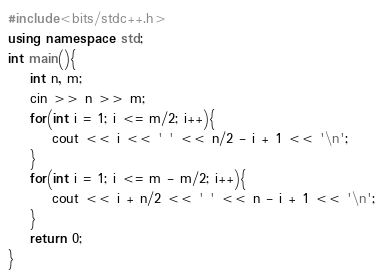<code> <loc_0><loc_0><loc_500><loc_500><_C++_>#include<bits/stdc++.h>
using namespace std;
int main(){
    int n, m;
    cin >> n >> m;
    for(int i = 1; i <= m/2; i++){
        cout << i << ' ' << n/2 - i + 1 << '\n';
    }
    for(int i = 1; i <= m - m/2; i++){
        cout << i + n/2 << ' ' << n - i + 1 << '\n';
    }
    return 0;
}</code> 